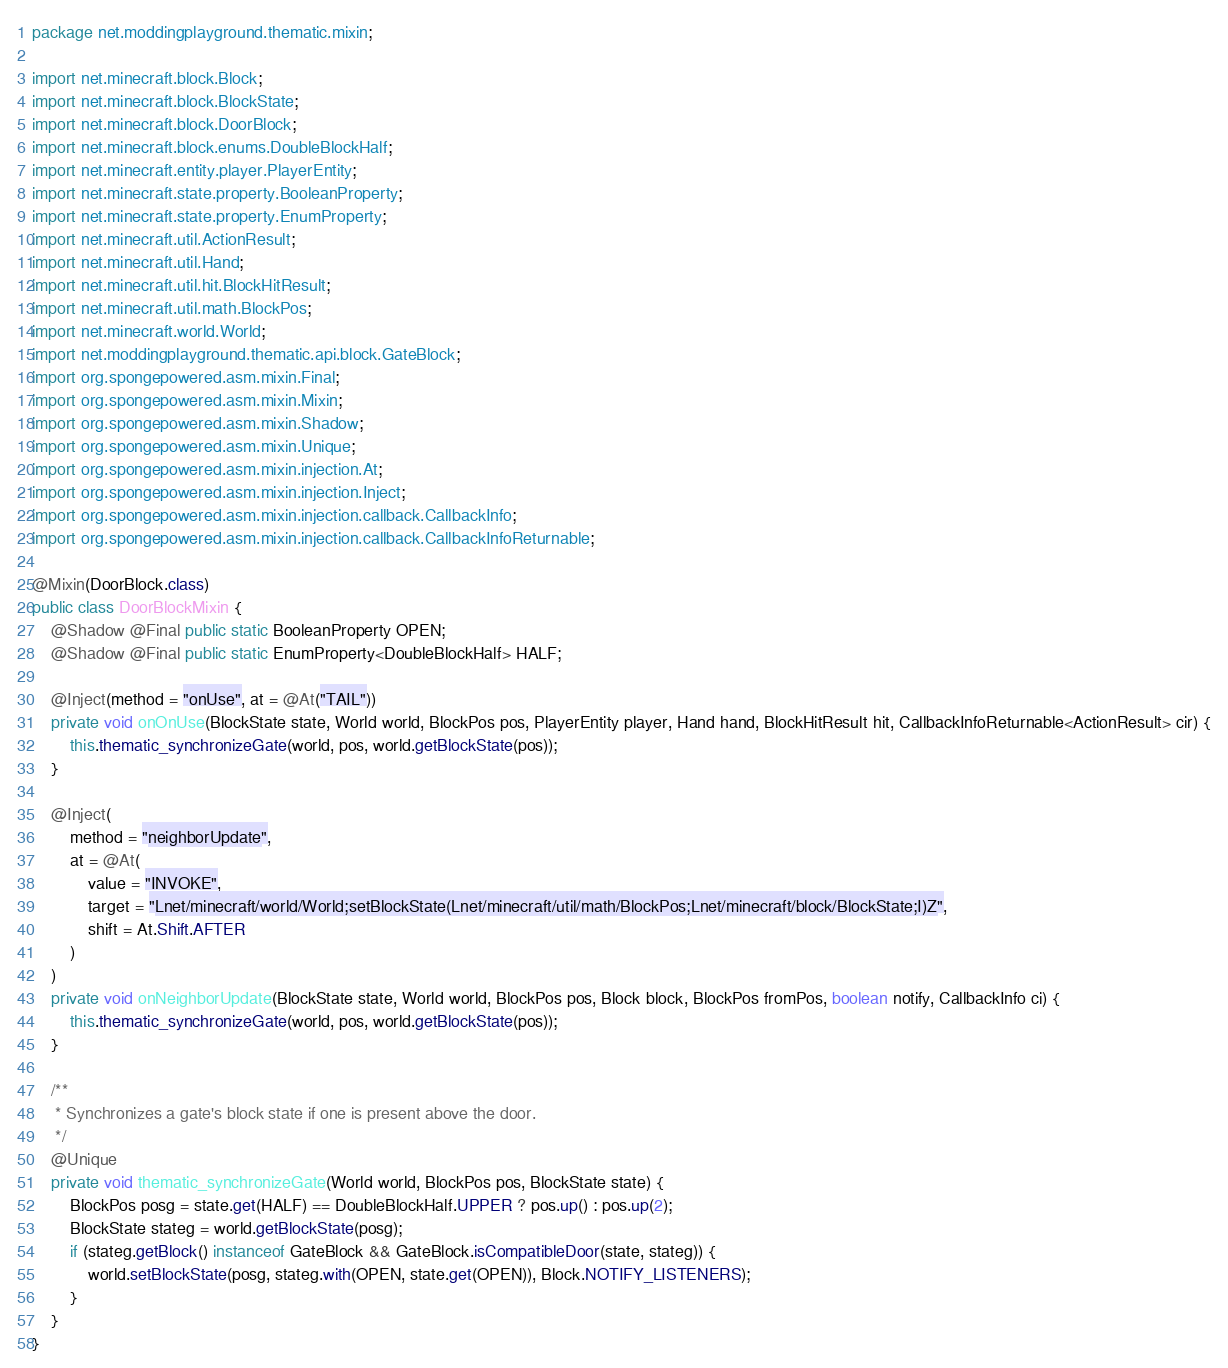<code> <loc_0><loc_0><loc_500><loc_500><_Java_>package net.moddingplayground.thematic.mixin;

import net.minecraft.block.Block;
import net.minecraft.block.BlockState;
import net.minecraft.block.DoorBlock;
import net.minecraft.block.enums.DoubleBlockHalf;
import net.minecraft.entity.player.PlayerEntity;
import net.minecraft.state.property.BooleanProperty;
import net.minecraft.state.property.EnumProperty;
import net.minecraft.util.ActionResult;
import net.minecraft.util.Hand;
import net.minecraft.util.hit.BlockHitResult;
import net.minecraft.util.math.BlockPos;
import net.minecraft.world.World;
import net.moddingplayground.thematic.api.block.GateBlock;
import org.spongepowered.asm.mixin.Final;
import org.spongepowered.asm.mixin.Mixin;
import org.spongepowered.asm.mixin.Shadow;
import org.spongepowered.asm.mixin.Unique;
import org.spongepowered.asm.mixin.injection.At;
import org.spongepowered.asm.mixin.injection.Inject;
import org.spongepowered.asm.mixin.injection.callback.CallbackInfo;
import org.spongepowered.asm.mixin.injection.callback.CallbackInfoReturnable;

@Mixin(DoorBlock.class)
public class DoorBlockMixin {
    @Shadow @Final public static BooleanProperty OPEN;
    @Shadow @Final public static EnumProperty<DoubleBlockHalf> HALF;

    @Inject(method = "onUse", at = @At("TAIL"))
    private void onOnUse(BlockState state, World world, BlockPos pos, PlayerEntity player, Hand hand, BlockHitResult hit, CallbackInfoReturnable<ActionResult> cir) {
        this.thematic_synchronizeGate(world, pos, world.getBlockState(pos));
    }

    @Inject(
        method = "neighborUpdate",
        at = @At(
            value = "INVOKE",
            target = "Lnet/minecraft/world/World;setBlockState(Lnet/minecraft/util/math/BlockPos;Lnet/minecraft/block/BlockState;I)Z",
            shift = At.Shift.AFTER
        )
    )
    private void onNeighborUpdate(BlockState state, World world, BlockPos pos, Block block, BlockPos fromPos, boolean notify, CallbackInfo ci) {
        this.thematic_synchronizeGate(world, pos, world.getBlockState(pos));
    }

    /**
     * Synchronizes a gate's block state if one is present above the door.
     */
    @Unique
    private void thematic_synchronizeGate(World world, BlockPos pos, BlockState state) {
        BlockPos posg = state.get(HALF) == DoubleBlockHalf.UPPER ? pos.up() : pos.up(2);
        BlockState stateg = world.getBlockState(posg);
        if (stateg.getBlock() instanceof GateBlock && GateBlock.isCompatibleDoor(state, stateg)) {
            world.setBlockState(posg, stateg.with(OPEN, state.get(OPEN)), Block.NOTIFY_LISTENERS);
        }
    }
}
</code> 